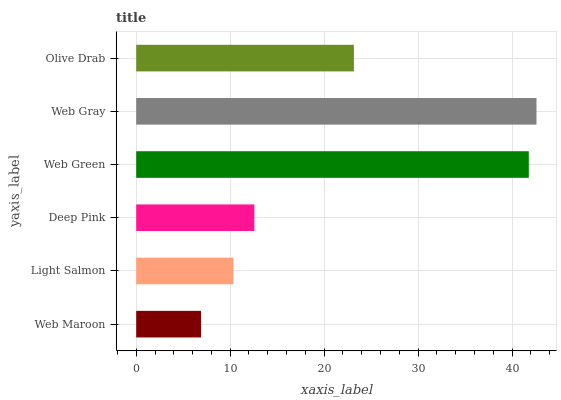Is Web Maroon the minimum?
Answer yes or no. Yes. Is Web Gray the maximum?
Answer yes or no. Yes. Is Light Salmon the minimum?
Answer yes or no. No. Is Light Salmon the maximum?
Answer yes or no. No. Is Light Salmon greater than Web Maroon?
Answer yes or no. Yes. Is Web Maroon less than Light Salmon?
Answer yes or no. Yes. Is Web Maroon greater than Light Salmon?
Answer yes or no. No. Is Light Salmon less than Web Maroon?
Answer yes or no. No. Is Olive Drab the high median?
Answer yes or no. Yes. Is Deep Pink the low median?
Answer yes or no. Yes. Is Web Maroon the high median?
Answer yes or no. No. Is Web Gray the low median?
Answer yes or no. No. 